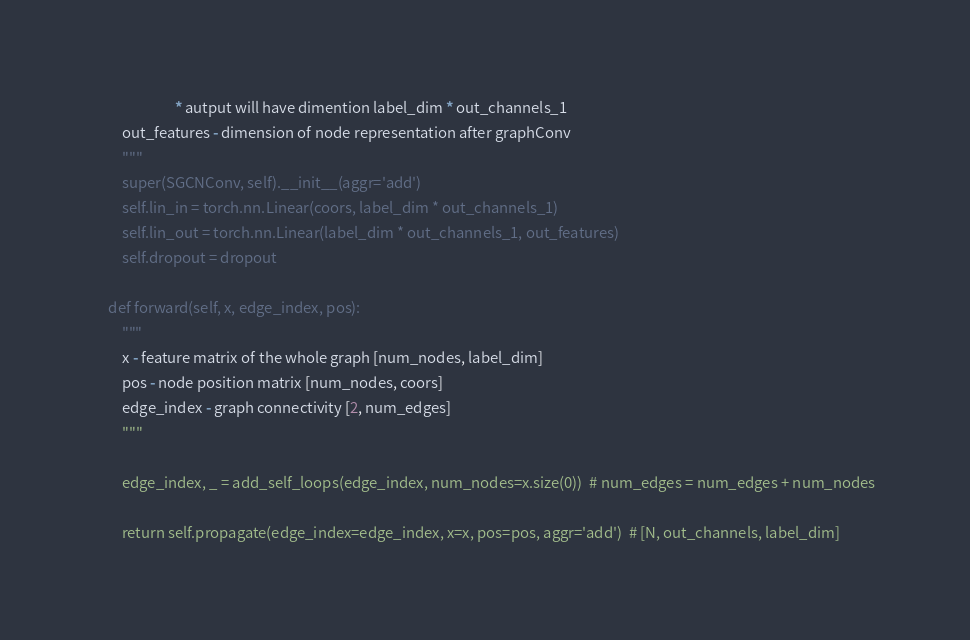<code> <loc_0><loc_0><loc_500><loc_500><_Python_>                        * autput will have dimention label_dim * out_channels_1
        out_features - dimension of node representation after graphConv
        """
        super(SGCNConv, self).__init__(aggr='add')
        self.lin_in = torch.nn.Linear(coors, label_dim * out_channels_1)
        self.lin_out = torch.nn.Linear(label_dim * out_channels_1, out_features)
        self.dropout = dropout

    def forward(self, x, edge_index, pos):
        """
        x - feature matrix of the whole graph [num_nodes, label_dim]
        pos - node position matrix [num_nodes, coors]
        edge_index - graph connectivity [2, num_edges]
        """

        edge_index, _ = add_self_loops(edge_index, num_nodes=x.size(0))  # num_edges = num_edges + num_nodes

        return self.propagate(edge_index=edge_index, x=x, pos=pos, aggr='add')  # [N, out_channels, label_dim]
</code> 